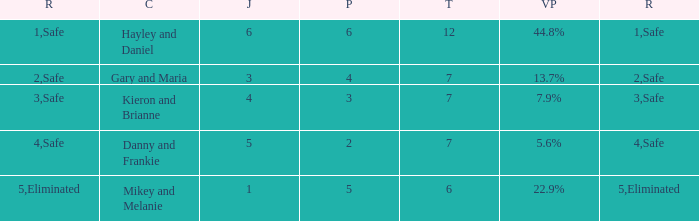What is the number of public that was there when the vote percentage was 22.9%? 1.0. 